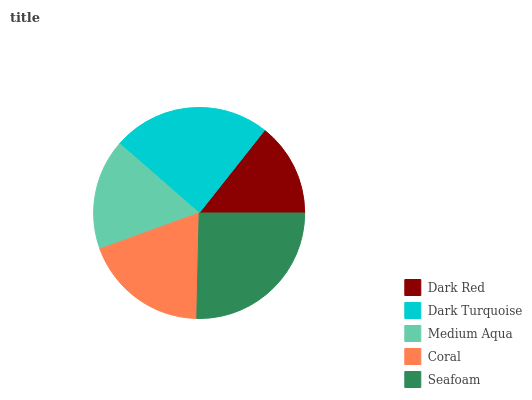Is Dark Red the minimum?
Answer yes or no. Yes. Is Seafoam the maximum?
Answer yes or no. Yes. Is Dark Turquoise the minimum?
Answer yes or no. No. Is Dark Turquoise the maximum?
Answer yes or no. No. Is Dark Turquoise greater than Dark Red?
Answer yes or no. Yes. Is Dark Red less than Dark Turquoise?
Answer yes or no. Yes. Is Dark Red greater than Dark Turquoise?
Answer yes or no. No. Is Dark Turquoise less than Dark Red?
Answer yes or no. No. Is Coral the high median?
Answer yes or no. Yes. Is Coral the low median?
Answer yes or no. Yes. Is Seafoam the high median?
Answer yes or no. No. Is Dark Red the low median?
Answer yes or no. No. 